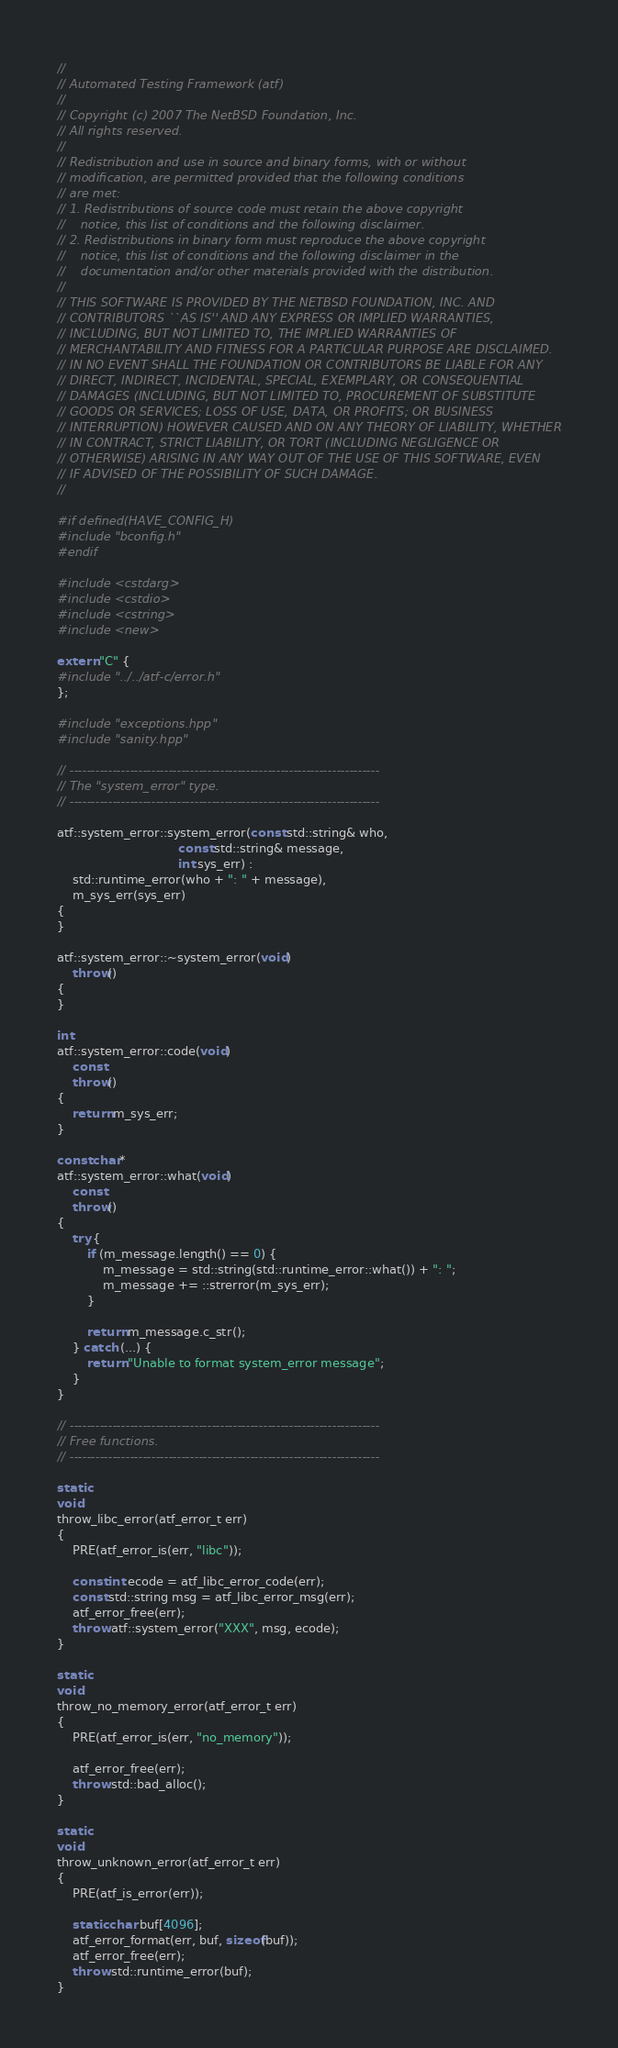Convert code to text. <code><loc_0><loc_0><loc_500><loc_500><_C++_>//
// Automated Testing Framework (atf)
//
// Copyright (c) 2007 The NetBSD Foundation, Inc.
// All rights reserved.
//
// Redistribution and use in source and binary forms, with or without
// modification, are permitted provided that the following conditions
// are met:
// 1. Redistributions of source code must retain the above copyright
//    notice, this list of conditions and the following disclaimer.
// 2. Redistributions in binary form must reproduce the above copyright
//    notice, this list of conditions and the following disclaimer in the
//    documentation and/or other materials provided with the distribution.
//
// THIS SOFTWARE IS PROVIDED BY THE NETBSD FOUNDATION, INC. AND
// CONTRIBUTORS ``AS IS'' AND ANY EXPRESS OR IMPLIED WARRANTIES,
// INCLUDING, BUT NOT LIMITED TO, THE IMPLIED WARRANTIES OF
// MERCHANTABILITY AND FITNESS FOR A PARTICULAR PURPOSE ARE DISCLAIMED.
// IN NO EVENT SHALL THE FOUNDATION OR CONTRIBUTORS BE LIABLE FOR ANY
// DIRECT, INDIRECT, INCIDENTAL, SPECIAL, EXEMPLARY, OR CONSEQUENTIAL
// DAMAGES (INCLUDING, BUT NOT LIMITED TO, PROCUREMENT OF SUBSTITUTE
// GOODS OR SERVICES; LOSS OF USE, DATA, OR PROFITS; OR BUSINESS
// INTERRUPTION) HOWEVER CAUSED AND ON ANY THEORY OF LIABILITY, WHETHER
// IN CONTRACT, STRICT LIABILITY, OR TORT (INCLUDING NEGLIGENCE OR
// OTHERWISE) ARISING IN ANY WAY OUT OF THE USE OF THIS SOFTWARE, EVEN
// IF ADVISED OF THE POSSIBILITY OF SUCH DAMAGE.
//

#if defined(HAVE_CONFIG_H)
#include "bconfig.h"
#endif

#include <cstdarg>
#include <cstdio>
#include <cstring>
#include <new>

extern "C" {
#include "../../atf-c/error.h"
};

#include "exceptions.hpp"
#include "sanity.hpp"

// ------------------------------------------------------------------------
// The "system_error" type.
// ------------------------------------------------------------------------

atf::system_error::system_error(const std::string& who,
                                const std::string& message,
                                int sys_err) :
    std::runtime_error(who + ": " + message),
    m_sys_err(sys_err)
{
}

atf::system_error::~system_error(void)
    throw()
{
}

int
atf::system_error::code(void)
    const
    throw()
{
    return m_sys_err;
}

const char*
atf::system_error::what(void)
    const
    throw()
{
    try {
        if (m_message.length() == 0) {
            m_message = std::string(std::runtime_error::what()) + ": ";
            m_message += ::strerror(m_sys_err);
        }

        return m_message.c_str();
    } catch (...) {
        return "Unable to format system_error message";
    }
}

// ------------------------------------------------------------------------
// Free functions.
// ------------------------------------------------------------------------

static
void
throw_libc_error(atf_error_t err)
{
    PRE(atf_error_is(err, "libc"));

    const int ecode = atf_libc_error_code(err);
    const std::string msg = atf_libc_error_msg(err);
    atf_error_free(err);
    throw atf::system_error("XXX", msg, ecode);
}

static
void
throw_no_memory_error(atf_error_t err)
{
    PRE(atf_error_is(err, "no_memory"));

    atf_error_free(err);
    throw std::bad_alloc();
}

static
void
throw_unknown_error(atf_error_t err)
{
    PRE(atf_is_error(err));

    static char buf[4096];
    atf_error_format(err, buf, sizeof(buf));
    atf_error_free(err);
    throw std::runtime_error(buf);
}
</code> 